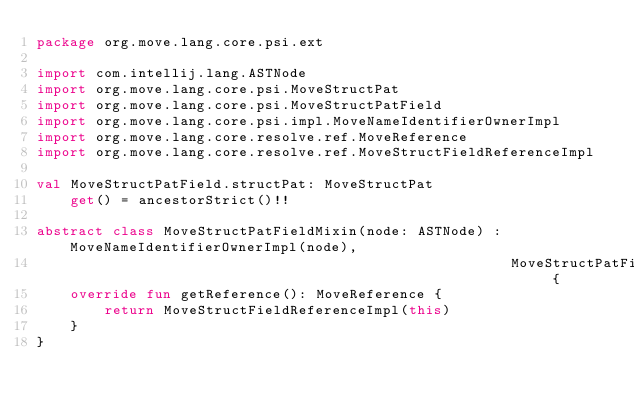<code> <loc_0><loc_0><loc_500><loc_500><_Kotlin_>package org.move.lang.core.psi.ext

import com.intellij.lang.ASTNode
import org.move.lang.core.psi.MoveStructPat
import org.move.lang.core.psi.MoveStructPatField
import org.move.lang.core.psi.impl.MoveNameIdentifierOwnerImpl
import org.move.lang.core.resolve.ref.MoveReference
import org.move.lang.core.resolve.ref.MoveStructFieldReferenceImpl

val MoveStructPatField.structPat: MoveStructPat
    get() = ancestorStrict()!!

abstract class MoveStructPatFieldMixin(node: ASTNode) : MoveNameIdentifierOwnerImpl(node),
                                                        MoveStructPatField {
    override fun getReference(): MoveReference {
        return MoveStructFieldReferenceImpl(this)
    }
}</code> 